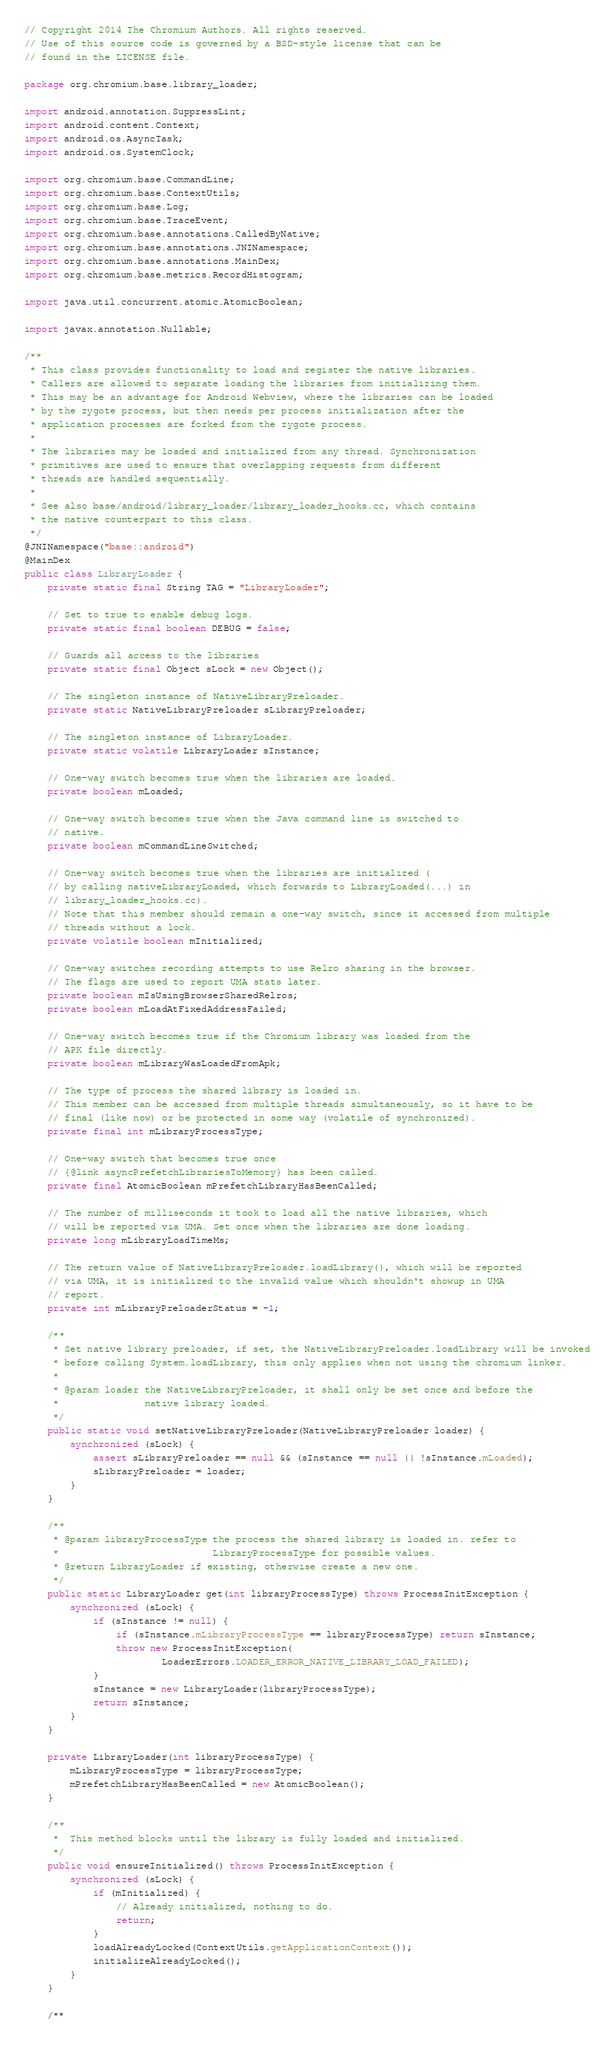<code> <loc_0><loc_0><loc_500><loc_500><_Java_>// Copyright 2014 The Chromium Authors. All rights reserved.
// Use of this source code is governed by a BSD-style license that can be
// found in the LICENSE file.

package org.chromium.base.library_loader;

import android.annotation.SuppressLint;
import android.content.Context;
import android.os.AsyncTask;
import android.os.SystemClock;

import org.chromium.base.CommandLine;
import org.chromium.base.ContextUtils;
import org.chromium.base.Log;
import org.chromium.base.TraceEvent;
import org.chromium.base.annotations.CalledByNative;
import org.chromium.base.annotations.JNINamespace;
import org.chromium.base.annotations.MainDex;
import org.chromium.base.metrics.RecordHistogram;

import java.util.concurrent.atomic.AtomicBoolean;

import javax.annotation.Nullable;

/**
 * This class provides functionality to load and register the native libraries.
 * Callers are allowed to separate loading the libraries from initializing them.
 * This may be an advantage for Android Webview, where the libraries can be loaded
 * by the zygote process, but then needs per process initialization after the
 * application processes are forked from the zygote process.
 *
 * The libraries may be loaded and initialized from any thread. Synchronization
 * primitives are used to ensure that overlapping requests from different
 * threads are handled sequentially.
 *
 * See also base/android/library_loader/library_loader_hooks.cc, which contains
 * the native counterpart to this class.
 */
@JNINamespace("base::android")
@MainDex
public class LibraryLoader {
    private static final String TAG = "LibraryLoader";

    // Set to true to enable debug logs.
    private static final boolean DEBUG = false;

    // Guards all access to the libraries
    private static final Object sLock = new Object();

    // The singleton instance of NativeLibraryPreloader.
    private static NativeLibraryPreloader sLibraryPreloader;

    // The singleton instance of LibraryLoader.
    private static volatile LibraryLoader sInstance;

    // One-way switch becomes true when the libraries are loaded.
    private boolean mLoaded;

    // One-way switch becomes true when the Java command line is switched to
    // native.
    private boolean mCommandLineSwitched;

    // One-way switch becomes true when the libraries are initialized (
    // by calling nativeLibraryLoaded, which forwards to LibraryLoaded(...) in
    // library_loader_hooks.cc).
    // Note that this member should remain a one-way switch, since it accessed from multiple
    // threads without a lock.
    private volatile boolean mInitialized;

    // One-way switches recording attempts to use Relro sharing in the browser.
    // The flags are used to report UMA stats later.
    private boolean mIsUsingBrowserSharedRelros;
    private boolean mLoadAtFixedAddressFailed;

    // One-way switch becomes true if the Chromium library was loaded from the
    // APK file directly.
    private boolean mLibraryWasLoadedFromApk;

    // The type of process the shared library is loaded in.
    // This member can be accessed from multiple threads simultaneously, so it have to be
    // final (like now) or be protected in some way (volatile of synchronized).
    private final int mLibraryProcessType;

    // One-way switch that becomes true once
    // {@link asyncPrefetchLibrariesToMemory} has been called.
    private final AtomicBoolean mPrefetchLibraryHasBeenCalled;

    // The number of milliseconds it took to load all the native libraries, which
    // will be reported via UMA. Set once when the libraries are done loading.
    private long mLibraryLoadTimeMs;

    // The return value of NativeLibraryPreloader.loadLibrary(), which will be reported
    // via UMA, it is initialized to the invalid value which shouldn't showup in UMA
    // report.
    private int mLibraryPreloaderStatus = -1;

    /**
     * Set native library preloader, if set, the NativeLibraryPreloader.loadLibrary will be invoked
     * before calling System.loadLibrary, this only applies when not using the chromium linker.
     *
     * @param loader the NativeLibraryPreloader, it shall only be set once and before the
     *               native library loaded.
     */
    public static void setNativeLibraryPreloader(NativeLibraryPreloader loader) {
        synchronized (sLock) {
            assert sLibraryPreloader == null && (sInstance == null || !sInstance.mLoaded);
            sLibraryPreloader = loader;
        }
    }

    /**
     * @param libraryProcessType the process the shared library is loaded in. refer to
     *                           LibraryProcessType for possible values.
     * @return LibraryLoader if existing, otherwise create a new one.
     */
    public static LibraryLoader get(int libraryProcessType) throws ProcessInitException {
        synchronized (sLock) {
            if (sInstance != null) {
                if (sInstance.mLibraryProcessType == libraryProcessType) return sInstance;
                throw new ProcessInitException(
                        LoaderErrors.LOADER_ERROR_NATIVE_LIBRARY_LOAD_FAILED);
            }
            sInstance = new LibraryLoader(libraryProcessType);
            return sInstance;
        }
    }

    private LibraryLoader(int libraryProcessType) {
        mLibraryProcessType = libraryProcessType;
        mPrefetchLibraryHasBeenCalled = new AtomicBoolean();
    }

    /**
     *  This method blocks until the library is fully loaded and initialized.
     */
    public void ensureInitialized() throws ProcessInitException {
        synchronized (sLock) {
            if (mInitialized) {
                // Already initialized, nothing to do.
                return;
            }
            loadAlreadyLocked(ContextUtils.getApplicationContext());
            initializeAlreadyLocked();
        }
    }

    /**</code> 